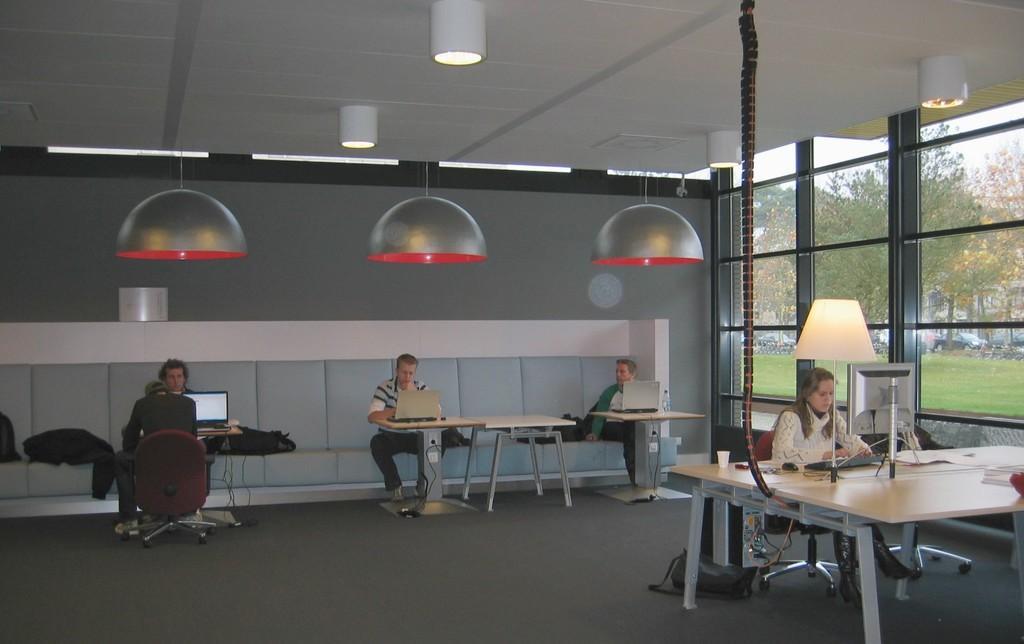How would you summarize this image in a sentence or two? The picture is clicked inside a room , there are many people sitting in front of the table. All these guys are operating their monitors. To the background there is a grey color wall and their is a designed roof which has lights and hanging all over the place. 